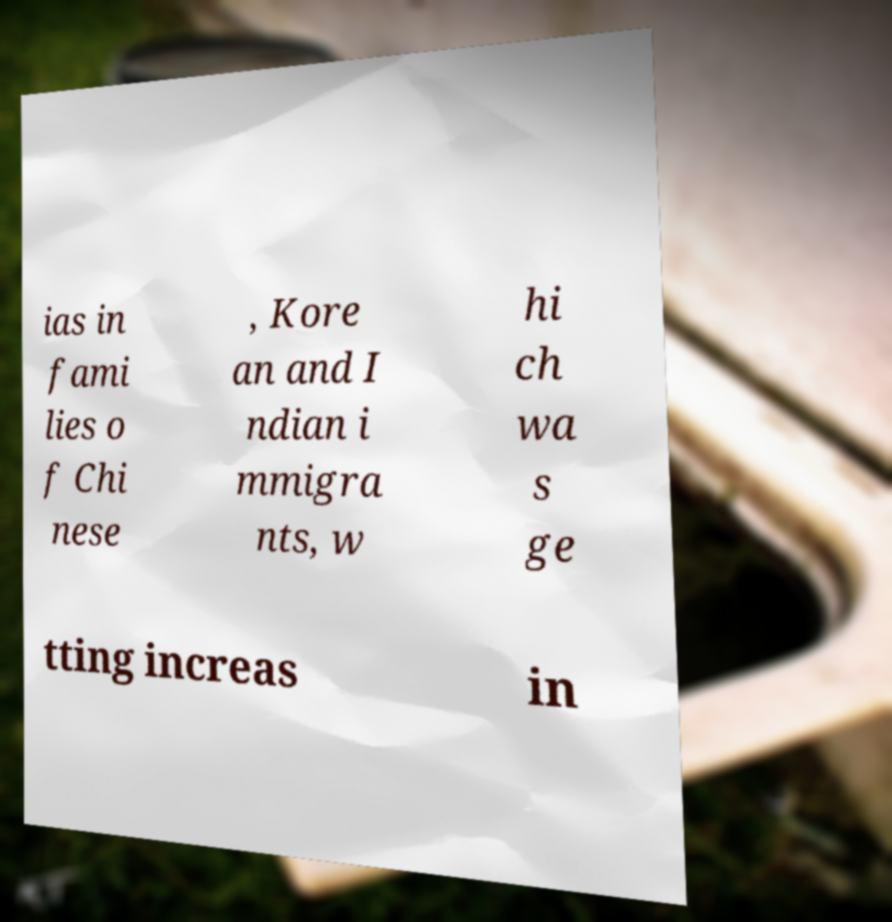For documentation purposes, I need the text within this image transcribed. Could you provide that? ias in fami lies o f Chi nese , Kore an and I ndian i mmigra nts, w hi ch wa s ge tting increas in 